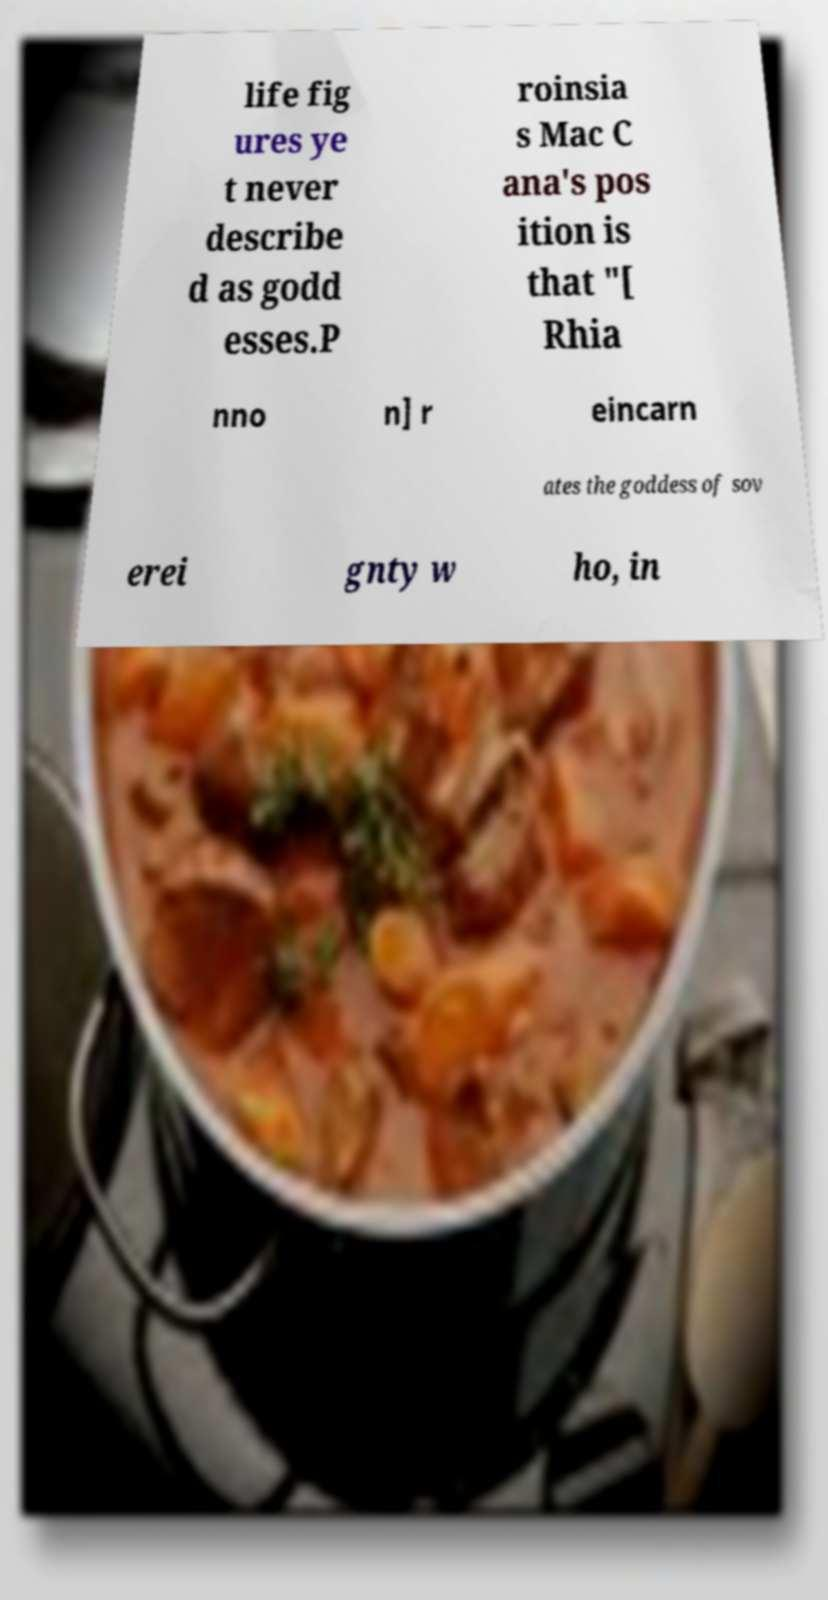There's text embedded in this image that I need extracted. Can you transcribe it verbatim? life fig ures ye t never describe d as godd esses.P roinsia s Mac C ana's pos ition is that "[ Rhia nno n] r eincarn ates the goddess of sov erei gnty w ho, in 